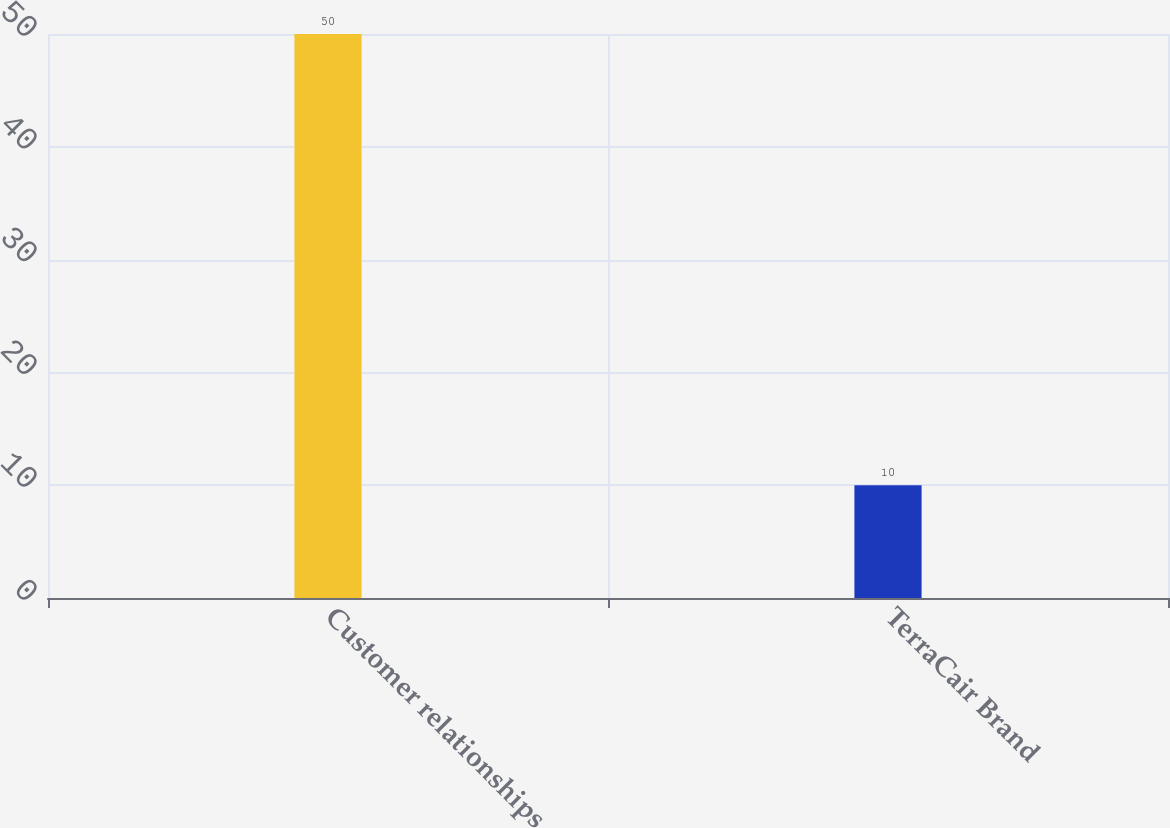Convert chart to OTSL. <chart><loc_0><loc_0><loc_500><loc_500><bar_chart><fcel>Customer relationships<fcel>TerraCair Brand<nl><fcel>50<fcel>10<nl></chart> 